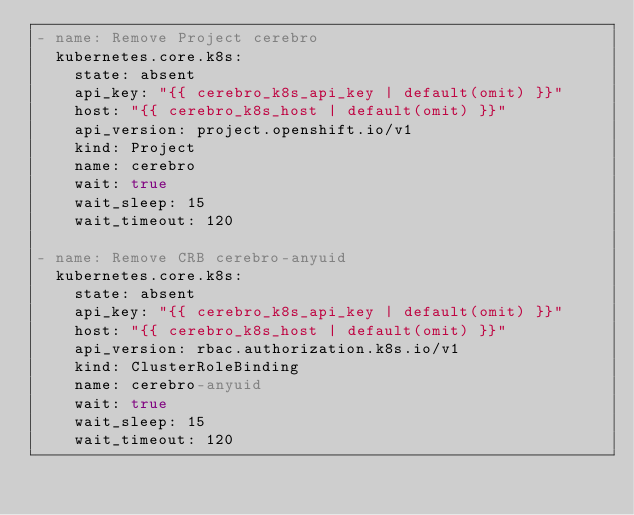<code> <loc_0><loc_0><loc_500><loc_500><_YAML_>- name: Remove Project cerebro
  kubernetes.core.k8s:
    state: absent
    api_key: "{{ cerebro_k8s_api_key | default(omit) }}"
    host: "{{ cerebro_k8s_host | default(omit) }}"
    api_version: project.openshift.io/v1
    kind: Project
    name: cerebro
    wait: true
    wait_sleep: 15
    wait_timeout: 120

- name: Remove CRB cerebro-anyuid
  kubernetes.core.k8s:
    state: absent
    api_key: "{{ cerebro_k8s_api_key | default(omit) }}"
    host: "{{ cerebro_k8s_host | default(omit) }}"
    api_version: rbac.authorization.k8s.io/v1
    kind: ClusterRoleBinding
    name: cerebro-anyuid
    wait: true
    wait_sleep: 15
    wait_timeout: 120
</code> 